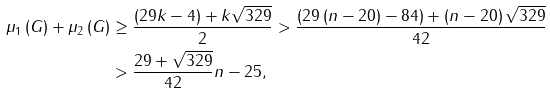<formula> <loc_0><loc_0><loc_500><loc_500>\mu _ { 1 } \left ( G \right ) + \mu _ { 2 } \left ( G \right ) & \geq \frac { \left ( 2 9 k - 4 \right ) + k \sqrt { 3 2 9 } } { 2 } > \frac { \left ( 2 9 \left ( n - 2 0 \right ) - 8 4 \right ) + \left ( n - 2 0 \right ) \sqrt { 3 2 9 } } { 4 2 } \\ & > \frac { 2 9 + \sqrt { 3 2 9 } } { 4 2 } n - 2 5 ,</formula> 